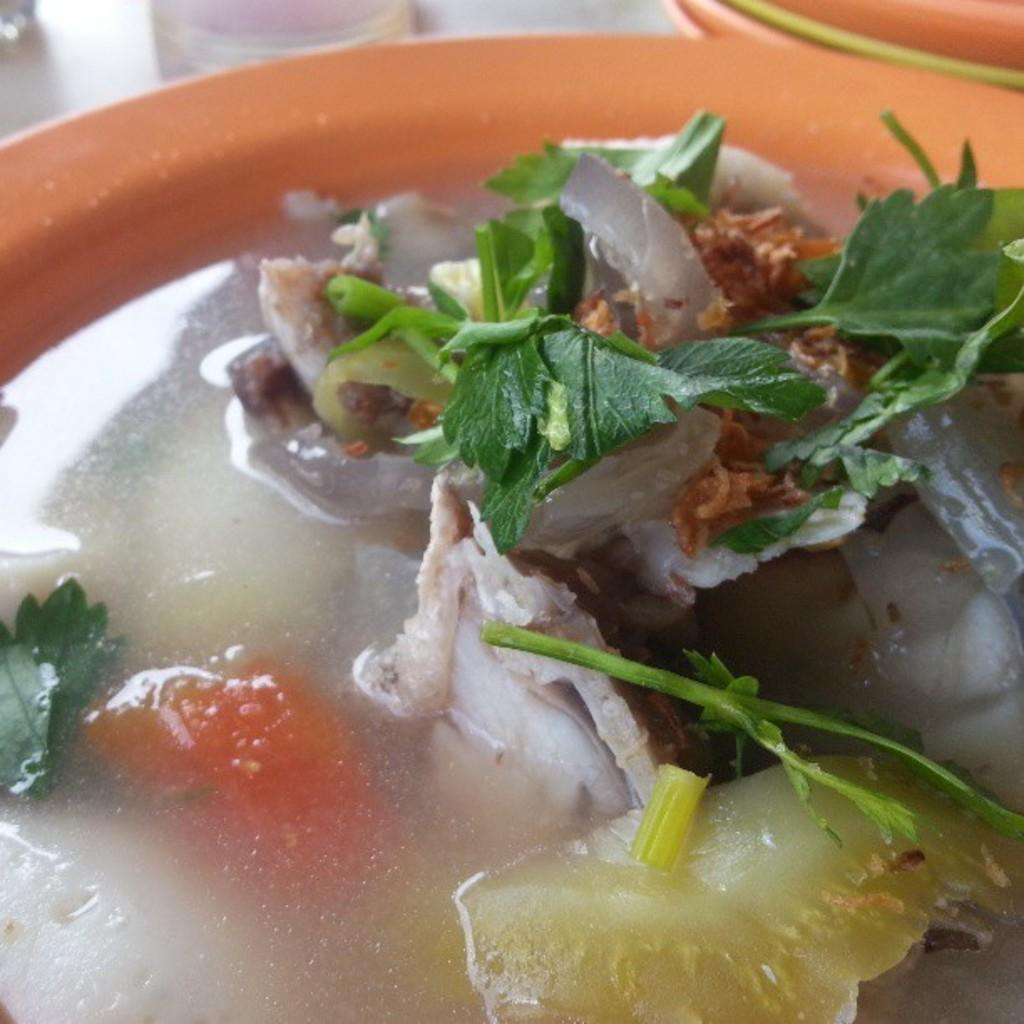What is present on the plate in the image? There is food in a plate in the image. What type of quill can be seen writing on the plate in the image? There is no quill present in the image, and the food on the plate is not being written on. 